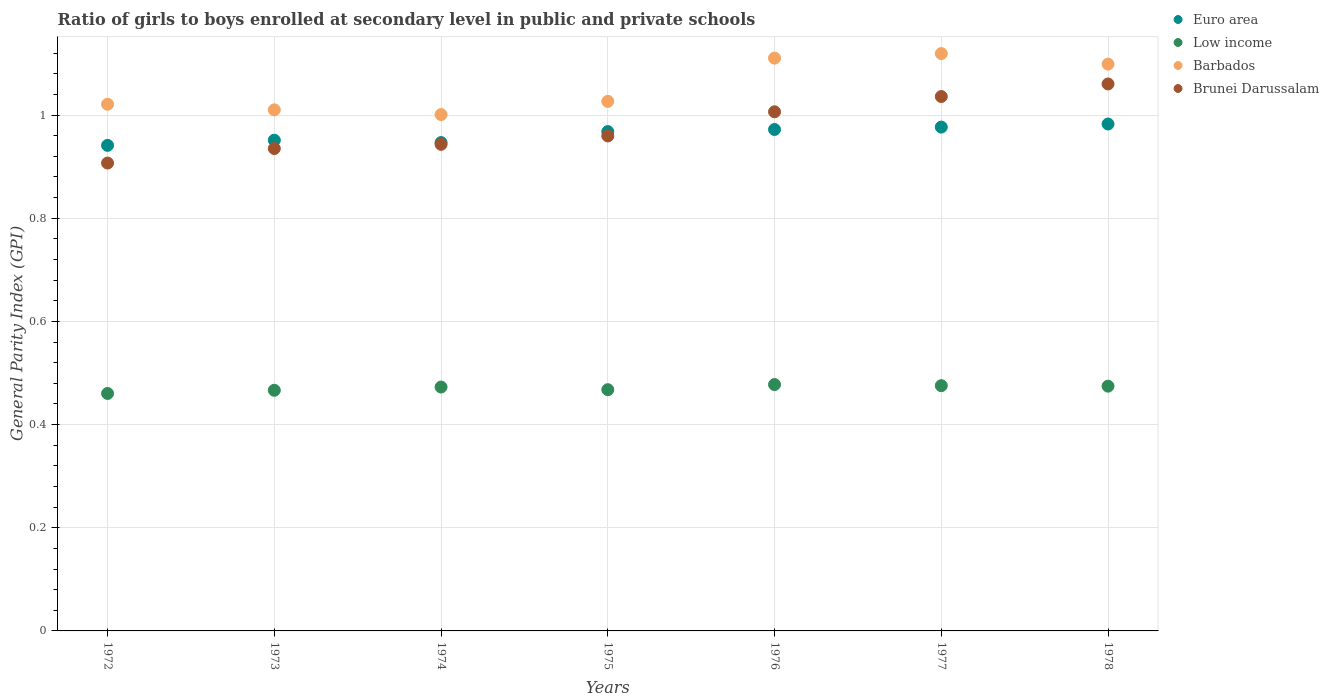How many different coloured dotlines are there?
Ensure brevity in your answer.  4. What is the general parity index in Low income in 1972?
Ensure brevity in your answer.  0.46. Across all years, what is the maximum general parity index in Brunei Darussalam?
Give a very brief answer. 1.06. Across all years, what is the minimum general parity index in Brunei Darussalam?
Offer a terse response. 0.91. In which year was the general parity index in Brunei Darussalam maximum?
Give a very brief answer. 1978. What is the total general parity index in Brunei Darussalam in the graph?
Provide a succinct answer. 6.85. What is the difference between the general parity index in Brunei Darussalam in 1973 and that in 1974?
Provide a short and direct response. -0.01. What is the difference between the general parity index in Low income in 1973 and the general parity index in Brunei Darussalam in 1977?
Provide a short and direct response. -0.57. What is the average general parity index in Brunei Darussalam per year?
Offer a terse response. 0.98. In the year 1974, what is the difference between the general parity index in Euro area and general parity index in Barbados?
Give a very brief answer. -0.05. In how many years, is the general parity index in Low income greater than 0.12?
Offer a terse response. 7. What is the ratio of the general parity index in Brunei Darussalam in 1977 to that in 1978?
Your response must be concise. 0.98. What is the difference between the highest and the second highest general parity index in Low income?
Your answer should be very brief. 0. What is the difference between the highest and the lowest general parity index in Barbados?
Provide a short and direct response. 0.12. Is it the case that in every year, the sum of the general parity index in Barbados and general parity index in Euro area  is greater than the sum of general parity index in Brunei Darussalam and general parity index in Low income?
Offer a terse response. No. Is it the case that in every year, the sum of the general parity index in Euro area and general parity index in Barbados  is greater than the general parity index in Brunei Darussalam?
Ensure brevity in your answer.  Yes. Is the general parity index in Barbados strictly greater than the general parity index in Euro area over the years?
Your answer should be very brief. Yes. Is the general parity index in Euro area strictly less than the general parity index in Barbados over the years?
Your answer should be very brief. Yes. How many dotlines are there?
Give a very brief answer. 4. How many years are there in the graph?
Offer a terse response. 7. What is the difference between two consecutive major ticks on the Y-axis?
Your answer should be very brief. 0.2. Does the graph contain grids?
Give a very brief answer. Yes. Where does the legend appear in the graph?
Provide a short and direct response. Top right. What is the title of the graph?
Your answer should be very brief. Ratio of girls to boys enrolled at secondary level in public and private schools. What is the label or title of the Y-axis?
Offer a terse response. General Parity Index (GPI). What is the General Parity Index (GPI) in Euro area in 1972?
Give a very brief answer. 0.94. What is the General Parity Index (GPI) in Low income in 1972?
Offer a very short reply. 0.46. What is the General Parity Index (GPI) of Barbados in 1972?
Offer a very short reply. 1.02. What is the General Parity Index (GPI) in Brunei Darussalam in 1972?
Your response must be concise. 0.91. What is the General Parity Index (GPI) in Euro area in 1973?
Provide a succinct answer. 0.95. What is the General Parity Index (GPI) of Low income in 1973?
Make the answer very short. 0.47. What is the General Parity Index (GPI) in Barbados in 1973?
Ensure brevity in your answer.  1.01. What is the General Parity Index (GPI) of Brunei Darussalam in 1973?
Ensure brevity in your answer.  0.94. What is the General Parity Index (GPI) of Euro area in 1974?
Ensure brevity in your answer.  0.95. What is the General Parity Index (GPI) of Low income in 1974?
Your answer should be compact. 0.47. What is the General Parity Index (GPI) in Barbados in 1974?
Your answer should be compact. 1. What is the General Parity Index (GPI) of Brunei Darussalam in 1974?
Provide a short and direct response. 0.94. What is the General Parity Index (GPI) in Euro area in 1975?
Provide a succinct answer. 0.97. What is the General Parity Index (GPI) of Low income in 1975?
Your answer should be very brief. 0.47. What is the General Parity Index (GPI) in Barbados in 1975?
Ensure brevity in your answer.  1.03. What is the General Parity Index (GPI) in Brunei Darussalam in 1975?
Provide a succinct answer. 0.96. What is the General Parity Index (GPI) of Euro area in 1976?
Your answer should be very brief. 0.97. What is the General Parity Index (GPI) in Low income in 1976?
Provide a short and direct response. 0.48. What is the General Parity Index (GPI) of Barbados in 1976?
Your response must be concise. 1.11. What is the General Parity Index (GPI) of Brunei Darussalam in 1976?
Provide a short and direct response. 1.01. What is the General Parity Index (GPI) of Euro area in 1977?
Your answer should be compact. 0.98. What is the General Parity Index (GPI) in Low income in 1977?
Provide a short and direct response. 0.48. What is the General Parity Index (GPI) of Barbados in 1977?
Give a very brief answer. 1.12. What is the General Parity Index (GPI) in Brunei Darussalam in 1977?
Give a very brief answer. 1.04. What is the General Parity Index (GPI) in Euro area in 1978?
Provide a succinct answer. 0.98. What is the General Parity Index (GPI) of Low income in 1978?
Make the answer very short. 0.47. What is the General Parity Index (GPI) in Barbados in 1978?
Offer a very short reply. 1.1. What is the General Parity Index (GPI) of Brunei Darussalam in 1978?
Your response must be concise. 1.06. Across all years, what is the maximum General Parity Index (GPI) in Euro area?
Offer a terse response. 0.98. Across all years, what is the maximum General Parity Index (GPI) of Low income?
Give a very brief answer. 0.48. Across all years, what is the maximum General Parity Index (GPI) of Barbados?
Your answer should be very brief. 1.12. Across all years, what is the maximum General Parity Index (GPI) of Brunei Darussalam?
Make the answer very short. 1.06. Across all years, what is the minimum General Parity Index (GPI) in Euro area?
Provide a short and direct response. 0.94. Across all years, what is the minimum General Parity Index (GPI) in Low income?
Your answer should be very brief. 0.46. Across all years, what is the minimum General Parity Index (GPI) in Barbados?
Your answer should be compact. 1. Across all years, what is the minimum General Parity Index (GPI) in Brunei Darussalam?
Make the answer very short. 0.91. What is the total General Parity Index (GPI) of Euro area in the graph?
Your answer should be compact. 6.74. What is the total General Parity Index (GPI) of Low income in the graph?
Provide a succinct answer. 3.29. What is the total General Parity Index (GPI) of Barbados in the graph?
Ensure brevity in your answer.  7.39. What is the total General Parity Index (GPI) of Brunei Darussalam in the graph?
Make the answer very short. 6.85. What is the difference between the General Parity Index (GPI) of Euro area in 1972 and that in 1973?
Provide a short and direct response. -0.01. What is the difference between the General Parity Index (GPI) of Low income in 1972 and that in 1973?
Provide a short and direct response. -0.01. What is the difference between the General Parity Index (GPI) in Barbados in 1972 and that in 1973?
Offer a terse response. 0.01. What is the difference between the General Parity Index (GPI) of Brunei Darussalam in 1972 and that in 1973?
Provide a short and direct response. -0.03. What is the difference between the General Parity Index (GPI) in Euro area in 1972 and that in 1974?
Your answer should be very brief. -0.01. What is the difference between the General Parity Index (GPI) in Low income in 1972 and that in 1974?
Provide a succinct answer. -0.01. What is the difference between the General Parity Index (GPI) of Brunei Darussalam in 1972 and that in 1974?
Give a very brief answer. -0.04. What is the difference between the General Parity Index (GPI) of Euro area in 1972 and that in 1975?
Your response must be concise. -0.03. What is the difference between the General Parity Index (GPI) of Low income in 1972 and that in 1975?
Your answer should be compact. -0.01. What is the difference between the General Parity Index (GPI) in Barbados in 1972 and that in 1975?
Your answer should be very brief. -0.01. What is the difference between the General Parity Index (GPI) in Brunei Darussalam in 1972 and that in 1975?
Your response must be concise. -0.05. What is the difference between the General Parity Index (GPI) of Euro area in 1972 and that in 1976?
Provide a short and direct response. -0.03. What is the difference between the General Parity Index (GPI) of Low income in 1972 and that in 1976?
Provide a succinct answer. -0.02. What is the difference between the General Parity Index (GPI) of Barbados in 1972 and that in 1976?
Offer a terse response. -0.09. What is the difference between the General Parity Index (GPI) in Brunei Darussalam in 1972 and that in 1976?
Offer a terse response. -0.1. What is the difference between the General Parity Index (GPI) in Euro area in 1972 and that in 1977?
Ensure brevity in your answer.  -0.04. What is the difference between the General Parity Index (GPI) of Low income in 1972 and that in 1977?
Make the answer very short. -0.02. What is the difference between the General Parity Index (GPI) of Barbados in 1972 and that in 1977?
Your response must be concise. -0.1. What is the difference between the General Parity Index (GPI) of Brunei Darussalam in 1972 and that in 1977?
Provide a short and direct response. -0.13. What is the difference between the General Parity Index (GPI) of Euro area in 1972 and that in 1978?
Give a very brief answer. -0.04. What is the difference between the General Parity Index (GPI) of Low income in 1972 and that in 1978?
Offer a very short reply. -0.01. What is the difference between the General Parity Index (GPI) of Barbados in 1972 and that in 1978?
Offer a very short reply. -0.08. What is the difference between the General Parity Index (GPI) in Brunei Darussalam in 1972 and that in 1978?
Your answer should be compact. -0.15. What is the difference between the General Parity Index (GPI) of Euro area in 1973 and that in 1974?
Ensure brevity in your answer.  0. What is the difference between the General Parity Index (GPI) in Low income in 1973 and that in 1974?
Your response must be concise. -0.01. What is the difference between the General Parity Index (GPI) in Barbados in 1973 and that in 1974?
Ensure brevity in your answer.  0.01. What is the difference between the General Parity Index (GPI) in Brunei Darussalam in 1973 and that in 1974?
Your answer should be very brief. -0.01. What is the difference between the General Parity Index (GPI) of Euro area in 1973 and that in 1975?
Provide a short and direct response. -0.02. What is the difference between the General Parity Index (GPI) in Low income in 1973 and that in 1975?
Keep it short and to the point. -0. What is the difference between the General Parity Index (GPI) of Barbados in 1973 and that in 1975?
Offer a terse response. -0.02. What is the difference between the General Parity Index (GPI) of Brunei Darussalam in 1973 and that in 1975?
Give a very brief answer. -0.02. What is the difference between the General Parity Index (GPI) of Euro area in 1973 and that in 1976?
Provide a short and direct response. -0.02. What is the difference between the General Parity Index (GPI) in Low income in 1973 and that in 1976?
Your answer should be very brief. -0.01. What is the difference between the General Parity Index (GPI) of Barbados in 1973 and that in 1976?
Your answer should be very brief. -0.1. What is the difference between the General Parity Index (GPI) in Brunei Darussalam in 1973 and that in 1976?
Provide a succinct answer. -0.07. What is the difference between the General Parity Index (GPI) of Euro area in 1973 and that in 1977?
Your response must be concise. -0.03. What is the difference between the General Parity Index (GPI) in Low income in 1973 and that in 1977?
Make the answer very short. -0.01. What is the difference between the General Parity Index (GPI) in Barbados in 1973 and that in 1977?
Keep it short and to the point. -0.11. What is the difference between the General Parity Index (GPI) in Brunei Darussalam in 1973 and that in 1977?
Offer a terse response. -0.1. What is the difference between the General Parity Index (GPI) of Euro area in 1973 and that in 1978?
Keep it short and to the point. -0.03. What is the difference between the General Parity Index (GPI) in Low income in 1973 and that in 1978?
Ensure brevity in your answer.  -0.01. What is the difference between the General Parity Index (GPI) in Barbados in 1973 and that in 1978?
Provide a succinct answer. -0.09. What is the difference between the General Parity Index (GPI) in Brunei Darussalam in 1973 and that in 1978?
Keep it short and to the point. -0.13. What is the difference between the General Parity Index (GPI) in Euro area in 1974 and that in 1975?
Give a very brief answer. -0.02. What is the difference between the General Parity Index (GPI) of Low income in 1974 and that in 1975?
Provide a short and direct response. 0.01. What is the difference between the General Parity Index (GPI) of Barbados in 1974 and that in 1975?
Ensure brevity in your answer.  -0.03. What is the difference between the General Parity Index (GPI) in Brunei Darussalam in 1974 and that in 1975?
Give a very brief answer. -0.02. What is the difference between the General Parity Index (GPI) of Euro area in 1974 and that in 1976?
Offer a terse response. -0.03. What is the difference between the General Parity Index (GPI) in Low income in 1974 and that in 1976?
Your answer should be very brief. -0. What is the difference between the General Parity Index (GPI) in Barbados in 1974 and that in 1976?
Provide a succinct answer. -0.11. What is the difference between the General Parity Index (GPI) in Brunei Darussalam in 1974 and that in 1976?
Provide a succinct answer. -0.06. What is the difference between the General Parity Index (GPI) of Euro area in 1974 and that in 1977?
Keep it short and to the point. -0.03. What is the difference between the General Parity Index (GPI) in Low income in 1974 and that in 1977?
Your answer should be compact. -0. What is the difference between the General Parity Index (GPI) in Barbados in 1974 and that in 1977?
Your response must be concise. -0.12. What is the difference between the General Parity Index (GPI) in Brunei Darussalam in 1974 and that in 1977?
Ensure brevity in your answer.  -0.09. What is the difference between the General Parity Index (GPI) of Euro area in 1974 and that in 1978?
Keep it short and to the point. -0.04. What is the difference between the General Parity Index (GPI) of Low income in 1974 and that in 1978?
Provide a short and direct response. -0. What is the difference between the General Parity Index (GPI) in Barbados in 1974 and that in 1978?
Your answer should be very brief. -0.1. What is the difference between the General Parity Index (GPI) in Brunei Darussalam in 1974 and that in 1978?
Provide a succinct answer. -0.12. What is the difference between the General Parity Index (GPI) in Euro area in 1975 and that in 1976?
Your response must be concise. -0. What is the difference between the General Parity Index (GPI) in Low income in 1975 and that in 1976?
Keep it short and to the point. -0.01. What is the difference between the General Parity Index (GPI) of Barbados in 1975 and that in 1976?
Ensure brevity in your answer.  -0.08. What is the difference between the General Parity Index (GPI) in Brunei Darussalam in 1975 and that in 1976?
Ensure brevity in your answer.  -0.05. What is the difference between the General Parity Index (GPI) in Euro area in 1975 and that in 1977?
Keep it short and to the point. -0.01. What is the difference between the General Parity Index (GPI) of Low income in 1975 and that in 1977?
Offer a very short reply. -0.01. What is the difference between the General Parity Index (GPI) in Barbados in 1975 and that in 1977?
Give a very brief answer. -0.09. What is the difference between the General Parity Index (GPI) of Brunei Darussalam in 1975 and that in 1977?
Make the answer very short. -0.08. What is the difference between the General Parity Index (GPI) in Euro area in 1975 and that in 1978?
Ensure brevity in your answer.  -0.01. What is the difference between the General Parity Index (GPI) of Low income in 1975 and that in 1978?
Offer a very short reply. -0.01. What is the difference between the General Parity Index (GPI) of Barbados in 1975 and that in 1978?
Provide a short and direct response. -0.07. What is the difference between the General Parity Index (GPI) of Brunei Darussalam in 1975 and that in 1978?
Offer a terse response. -0.1. What is the difference between the General Parity Index (GPI) in Euro area in 1976 and that in 1977?
Keep it short and to the point. -0. What is the difference between the General Parity Index (GPI) of Low income in 1976 and that in 1977?
Ensure brevity in your answer.  0. What is the difference between the General Parity Index (GPI) of Barbados in 1976 and that in 1977?
Offer a terse response. -0.01. What is the difference between the General Parity Index (GPI) of Brunei Darussalam in 1976 and that in 1977?
Offer a terse response. -0.03. What is the difference between the General Parity Index (GPI) in Euro area in 1976 and that in 1978?
Ensure brevity in your answer.  -0.01. What is the difference between the General Parity Index (GPI) in Low income in 1976 and that in 1978?
Give a very brief answer. 0. What is the difference between the General Parity Index (GPI) in Barbados in 1976 and that in 1978?
Your answer should be very brief. 0.01. What is the difference between the General Parity Index (GPI) of Brunei Darussalam in 1976 and that in 1978?
Keep it short and to the point. -0.05. What is the difference between the General Parity Index (GPI) in Euro area in 1977 and that in 1978?
Give a very brief answer. -0.01. What is the difference between the General Parity Index (GPI) in Barbados in 1977 and that in 1978?
Your response must be concise. 0.02. What is the difference between the General Parity Index (GPI) of Brunei Darussalam in 1977 and that in 1978?
Your answer should be very brief. -0.02. What is the difference between the General Parity Index (GPI) of Euro area in 1972 and the General Parity Index (GPI) of Low income in 1973?
Provide a succinct answer. 0.47. What is the difference between the General Parity Index (GPI) in Euro area in 1972 and the General Parity Index (GPI) in Barbados in 1973?
Offer a terse response. -0.07. What is the difference between the General Parity Index (GPI) of Euro area in 1972 and the General Parity Index (GPI) of Brunei Darussalam in 1973?
Provide a succinct answer. 0.01. What is the difference between the General Parity Index (GPI) in Low income in 1972 and the General Parity Index (GPI) in Barbados in 1973?
Offer a very short reply. -0.55. What is the difference between the General Parity Index (GPI) of Low income in 1972 and the General Parity Index (GPI) of Brunei Darussalam in 1973?
Ensure brevity in your answer.  -0.47. What is the difference between the General Parity Index (GPI) of Barbados in 1972 and the General Parity Index (GPI) of Brunei Darussalam in 1973?
Your answer should be compact. 0.09. What is the difference between the General Parity Index (GPI) in Euro area in 1972 and the General Parity Index (GPI) in Low income in 1974?
Give a very brief answer. 0.47. What is the difference between the General Parity Index (GPI) of Euro area in 1972 and the General Parity Index (GPI) of Barbados in 1974?
Keep it short and to the point. -0.06. What is the difference between the General Parity Index (GPI) of Euro area in 1972 and the General Parity Index (GPI) of Brunei Darussalam in 1974?
Make the answer very short. -0. What is the difference between the General Parity Index (GPI) of Low income in 1972 and the General Parity Index (GPI) of Barbados in 1974?
Provide a short and direct response. -0.54. What is the difference between the General Parity Index (GPI) in Low income in 1972 and the General Parity Index (GPI) in Brunei Darussalam in 1974?
Provide a short and direct response. -0.48. What is the difference between the General Parity Index (GPI) in Barbados in 1972 and the General Parity Index (GPI) in Brunei Darussalam in 1974?
Ensure brevity in your answer.  0.08. What is the difference between the General Parity Index (GPI) of Euro area in 1972 and the General Parity Index (GPI) of Low income in 1975?
Give a very brief answer. 0.47. What is the difference between the General Parity Index (GPI) in Euro area in 1972 and the General Parity Index (GPI) in Barbados in 1975?
Keep it short and to the point. -0.09. What is the difference between the General Parity Index (GPI) in Euro area in 1972 and the General Parity Index (GPI) in Brunei Darussalam in 1975?
Provide a succinct answer. -0.02. What is the difference between the General Parity Index (GPI) in Low income in 1972 and the General Parity Index (GPI) in Barbados in 1975?
Provide a succinct answer. -0.57. What is the difference between the General Parity Index (GPI) of Low income in 1972 and the General Parity Index (GPI) of Brunei Darussalam in 1975?
Offer a very short reply. -0.5. What is the difference between the General Parity Index (GPI) of Barbados in 1972 and the General Parity Index (GPI) of Brunei Darussalam in 1975?
Offer a very short reply. 0.06. What is the difference between the General Parity Index (GPI) of Euro area in 1972 and the General Parity Index (GPI) of Low income in 1976?
Provide a succinct answer. 0.46. What is the difference between the General Parity Index (GPI) in Euro area in 1972 and the General Parity Index (GPI) in Barbados in 1976?
Provide a succinct answer. -0.17. What is the difference between the General Parity Index (GPI) of Euro area in 1972 and the General Parity Index (GPI) of Brunei Darussalam in 1976?
Provide a succinct answer. -0.07. What is the difference between the General Parity Index (GPI) in Low income in 1972 and the General Parity Index (GPI) in Barbados in 1976?
Your answer should be compact. -0.65. What is the difference between the General Parity Index (GPI) of Low income in 1972 and the General Parity Index (GPI) of Brunei Darussalam in 1976?
Offer a very short reply. -0.55. What is the difference between the General Parity Index (GPI) of Barbados in 1972 and the General Parity Index (GPI) of Brunei Darussalam in 1976?
Keep it short and to the point. 0.01. What is the difference between the General Parity Index (GPI) in Euro area in 1972 and the General Parity Index (GPI) in Low income in 1977?
Your answer should be compact. 0.47. What is the difference between the General Parity Index (GPI) of Euro area in 1972 and the General Parity Index (GPI) of Barbados in 1977?
Your response must be concise. -0.18. What is the difference between the General Parity Index (GPI) in Euro area in 1972 and the General Parity Index (GPI) in Brunei Darussalam in 1977?
Your answer should be very brief. -0.09. What is the difference between the General Parity Index (GPI) in Low income in 1972 and the General Parity Index (GPI) in Barbados in 1977?
Ensure brevity in your answer.  -0.66. What is the difference between the General Parity Index (GPI) of Low income in 1972 and the General Parity Index (GPI) of Brunei Darussalam in 1977?
Offer a terse response. -0.58. What is the difference between the General Parity Index (GPI) in Barbados in 1972 and the General Parity Index (GPI) in Brunei Darussalam in 1977?
Your answer should be compact. -0.01. What is the difference between the General Parity Index (GPI) of Euro area in 1972 and the General Parity Index (GPI) of Low income in 1978?
Your response must be concise. 0.47. What is the difference between the General Parity Index (GPI) in Euro area in 1972 and the General Parity Index (GPI) in Barbados in 1978?
Provide a succinct answer. -0.16. What is the difference between the General Parity Index (GPI) of Euro area in 1972 and the General Parity Index (GPI) of Brunei Darussalam in 1978?
Your response must be concise. -0.12. What is the difference between the General Parity Index (GPI) of Low income in 1972 and the General Parity Index (GPI) of Barbados in 1978?
Make the answer very short. -0.64. What is the difference between the General Parity Index (GPI) of Low income in 1972 and the General Parity Index (GPI) of Brunei Darussalam in 1978?
Ensure brevity in your answer.  -0.6. What is the difference between the General Parity Index (GPI) of Barbados in 1972 and the General Parity Index (GPI) of Brunei Darussalam in 1978?
Your answer should be very brief. -0.04. What is the difference between the General Parity Index (GPI) in Euro area in 1973 and the General Parity Index (GPI) in Low income in 1974?
Offer a terse response. 0.48. What is the difference between the General Parity Index (GPI) in Euro area in 1973 and the General Parity Index (GPI) in Barbados in 1974?
Make the answer very short. -0.05. What is the difference between the General Parity Index (GPI) of Euro area in 1973 and the General Parity Index (GPI) of Brunei Darussalam in 1974?
Offer a very short reply. 0.01. What is the difference between the General Parity Index (GPI) in Low income in 1973 and the General Parity Index (GPI) in Barbados in 1974?
Make the answer very short. -0.53. What is the difference between the General Parity Index (GPI) in Low income in 1973 and the General Parity Index (GPI) in Brunei Darussalam in 1974?
Your answer should be very brief. -0.48. What is the difference between the General Parity Index (GPI) in Barbados in 1973 and the General Parity Index (GPI) in Brunei Darussalam in 1974?
Keep it short and to the point. 0.07. What is the difference between the General Parity Index (GPI) of Euro area in 1973 and the General Parity Index (GPI) of Low income in 1975?
Make the answer very short. 0.48. What is the difference between the General Parity Index (GPI) of Euro area in 1973 and the General Parity Index (GPI) of Barbados in 1975?
Offer a terse response. -0.08. What is the difference between the General Parity Index (GPI) in Euro area in 1973 and the General Parity Index (GPI) in Brunei Darussalam in 1975?
Your response must be concise. -0.01. What is the difference between the General Parity Index (GPI) in Low income in 1973 and the General Parity Index (GPI) in Barbados in 1975?
Provide a succinct answer. -0.56. What is the difference between the General Parity Index (GPI) of Low income in 1973 and the General Parity Index (GPI) of Brunei Darussalam in 1975?
Keep it short and to the point. -0.49. What is the difference between the General Parity Index (GPI) of Barbados in 1973 and the General Parity Index (GPI) of Brunei Darussalam in 1975?
Ensure brevity in your answer.  0.05. What is the difference between the General Parity Index (GPI) of Euro area in 1973 and the General Parity Index (GPI) of Low income in 1976?
Offer a terse response. 0.47. What is the difference between the General Parity Index (GPI) in Euro area in 1973 and the General Parity Index (GPI) in Barbados in 1976?
Offer a terse response. -0.16. What is the difference between the General Parity Index (GPI) in Euro area in 1973 and the General Parity Index (GPI) in Brunei Darussalam in 1976?
Your answer should be very brief. -0.06. What is the difference between the General Parity Index (GPI) of Low income in 1973 and the General Parity Index (GPI) of Barbados in 1976?
Ensure brevity in your answer.  -0.64. What is the difference between the General Parity Index (GPI) of Low income in 1973 and the General Parity Index (GPI) of Brunei Darussalam in 1976?
Provide a succinct answer. -0.54. What is the difference between the General Parity Index (GPI) of Barbados in 1973 and the General Parity Index (GPI) of Brunei Darussalam in 1976?
Offer a terse response. 0. What is the difference between the General Parity Index (GPI) of Euro area in 1973 and the General Parity Index (GPI) of Low income in 1977?
Provide a succinct answer. 0.48. What is the difference between the General Parity Index (GPI) of Euro area in 1973 and the General Parity Index (GPI) of Barbados in 1977?
Your answer should be compact. -0.17. What is the difference between the General Parity Index (GPI) in Euro area in 1973 and the General Parity Index (GPI) in Brunei Darussalam in 1977?
Your response must be concise. -0.08. What is the difference between the General Parity Index (GPI) of Low income in 1973 and the General Parity Index (GPI) of Barbados in 1977?
Your response must be concise. -0.65. What is the difference between the General Parity Index (GPI) in Low income in 1973 and the General Parity Index (GPI) in Brunei Darussalam in 1977?
Provide a short and direct response. -0.57. What is the difference between the General Parity Index (GPI) of Barbados in 1973 and the General Parity Index (GPI) of Brunei Darussalam in 1977?
Provide a succinct answer. -0.03. What is the difference between the General Parity Index (GPI) in Euro area in 1973 and the General Parity Index (GPI) in Low income in 1978?
Ensure brevity in your answer.  0.48. What is the difference between the General Parity Index (GPI) in Euro area in 1973 and the General Parity Index (GPI) in Barbados in 1978?
Offer a very short reply. -0.15. What is the difference between the General Parity Index (GPI) of Euro area in 1973 and the General Parity Index (GPI) of Brunei Darussalam in 1978?
Give a very brief answer. -0.11. What is the difference between the General Parity Index (GPI) in Low income in 1973 and the General Parity Index (GPI) in Barbados in 1978?
Provide a short and direct response. -0.63. What is the difference between the General Parity Index (GPI) in Low income in 1973 and the General Parity Index (GPI) in Brunei Darussalam in 1978?
Keep it short and to the point. -0.59. What is the difference between the General Parity Index (GPI) in Barbados in 1973 and the General Parity Index (GPI) in Brunei Darussalam in 1978?
Ensure brevity in your answer.  -0.05. What is the difference between the General Parity Index (GPI) of Euro area in 1974 and the General Parity Index (GPI) of Low income in 1975?
Offer a terse response. 0.48. What is the difference between the General Parity Index (GPI) of Euro area in 1974 and the General Parity Index (GPI) of Barbados in 1975?
Offer a terse response. -0.08. What is the difference between the General Parity Index (GPI) in Euro area in 1974 and the General Parity Index (GPI) in Brunei Darussalam in 1975?
Give a very brief answer. -0.01. What is the difference between the General Parity Index (GPI) in Low income in 1974 and the General Parity Index (GPI) in Barbados in 1975?
Offer a very short reply. -0.55. What is the difference between the General Parity Index (GPI) in Low income in 1974 and the General Parity Index (GPI) in Brunei Darussalam in 1975?
Give a very brief answer. -0.49. What is the difference between the General Parity Index (GPI) of Barbados in 1974 and the General Parity Index (GPI) of Brunei Darussalam in 1975?
Provide a short and direct response. 0.04. What is the difference between the General Parity Index (GPI) in Euro area in 1974 and the General Parity Index (GPI) in Low income in 1976?
Your answer should be very brief. 0.47. What is the difference between the General Parity Index (GPI) of Euro area in 1974 and the General Parity Index (GPI) of Barbados in 1976?
Your answer should be compact. -0.16. What is the difference between the General Parity Index (GPI) of Euro area in 1974 and the General Parity Index (GPI) of Brunei Darussalam in 1976?
Keep it short and to the point. -0.06. What is the difference between the General Parity Index (GPI) in Low income in 1974 and the General Parity Index (GPI) in Barbados in 1976?
Make the answer very short. -0.64. What is the difference between the General Parity Index (GPI) of Low income in 1974 and the General Parity Index (GPI) of Brunei Darussalam in 1976?
Offer a terse response. -0.53. What is the difference between the General Parity Index (GPI) of Barbados in 1974 and the General Parity Index (GPI) of Brunei Darussalam in 1976?
Your response must be concise. -0.01. What is the difference between the General Parity Index (GPI) in Euro area in 1974 and the General Parity Index (GPI) in Low income in 1977?
Your answer should be compact. 0.47. What is the difference between the General Parity Index (GPI) of Euro area in 1974 and the General Parity Index (GPI) of Barbados in 1977?
Offer a very short reply. -0.17. What is the difference between the General Parity Index (GPI) of Euro area in 1974 and the General Parity Index (GPI) of Brunei Darussalam in 1977?
Ensure brevity in your answer.  -0.09. What is the difference between the General Parity Index (GPI) of Low income in 1974 and the General Parity Index (GPI) of Barbados in 1977?
Offer a terse response. -0.65. What is the difference between the General Parity Index (GPI) of Low income in 1974 and the General Parity Index (GPI) of Brunei Darussalam in 1977?
Keep it short and to the point. -0.56. What is the difference between the General Parity Index (GPI) in Barbados in 1974 and the General Parity Index (GPI) in Brunei Darussalam in 1977?
Your response must be concise. -0.04. What is the difference between the General Parity Index (GPI) of Euro area in 1974 and the General Parity Index (GPI) of Low income in 1978?
Your answer should be very brief. 0.47. What is the difference between the General Parity Index (GPI) of Euro area in 1974 and the General Parity Index (GPI) of Barbados in 1978?
Your answer should be very brief. -0.15. What is the difference between the General Parity Index (GPI) of Euro area in 1974 and the General Parity Index (GPI) of Brunei Darussalam in 1978?
Your answer should be very brief. -0.11. What is the difference between the General Parity Index (GPI) of Low income in 1974 and the General Parity Index (GPI) of Barbados in 1978?
Offer a terse response. -0.63. What is the difference between the General Parity Index (GPI) of Low income in 1974 and the General Parity Index (GPI) of Brunei Darussalam in 1978?
Offer a terse response. -0.59. What is the difference between the General Parity Index (GPI) of Barbados in 1974 and the General Parity Index (GPI) of Brunei Darussalam in 1978?
Keep it short and to the point. -0.06. What is the difference between the General Parity Index (GPI) of Euro area in 1975 and the General Parity Index (GPI) of Low income in 1976?
Provide a succinct answer. 0.49. What is the difference between the General Parity Index (GPI) in Euro area in 1975 and the General Parity Index (GPI) in Barbados in 1976?
Give a very brief answer. -0.14. What is the difference between the General Parity Index (GPI) in Euro area in 1975 and the General Parity Index (GPI) in Brunei Darussalam in 1976?
Ensure brevity in your answer.  -0.04. What is the difference between the General Parity Index (GPI) in Low income in 1975 and the General Parity Index (GPI) in Barbados in 1976?
Ensure brevity in your answer.  -0.64. What is the difference between the General Parity Index (GPI) in Low income in 1975 and the General Parity Index (GPI) in Brunei Darussalam in 1976?
Keep it short and to the point. -0.54. What is the difference between the General Parity Index (GPI) of Barbados in 1975 and the General Parity Index (GPI) of Brunei Darussalam in 1976?
Your response must be concise. 0.02. What is the difference between the General Parity Index (GPI) of Euro area in 1975 and the General Parity Index (GPI) of Low income in 1977?
Offer a very short reply. 0.49. What is the difference between the General Parity Index (GPI) in Euro area in 1975 and the General Parity Index (GPI) in Barbados in 1977?
Provide a short and direct response. -0.15. What is the difference between the General Parity Index (GPI) in Euro area in 1975 and the General Parity Index (GPI) in Brunei Darussalam in 1977?
Your answer should be compact. -0.07. What is the difference between the General Parity Index (GPI) of Low income in 1975 and the General Parity Index (GPI) of Barbados in 1977?
Ensure brevity in your answer.  -0.65. What is the difference between the General Parity Index (GPI) in Low income in 1975 and the General Parity Index (GPI) in Brunei Darussalam in 1977?
Make the answer very short. -0.57. What is the difference between the General Parity Index (GPI) in Barbados in 1975 and the General Parity Index (GPI) in Brunei Darussalam in 1977?
Give a very brief answer. -0.01. What is the difference between the General Parity Index (GPI) in Euro area in 1975 and the General Parity Index (GPI) in Low income in 1978?
Ensure brevity in your answer.  0.49. What is the difference between the General Parity Index (GPI) of Euro area in 1975 and the General Parity Index (GPI) of Barbados in 1978?
Offer a terse response. -0.13. What is the difference between the General Parity Index (GPI) in Euro area in 1975 and the General Parity Index (GPI) in Brunei Darussalam in 1978?
Your response must be concise. -0.09. What is the difference between the General Parity Index (GPI) of Low income in 1975 and the General Parity Index (GPI) of Barbados in 1978?
Your response must be concise. -0.63. What is the difference between the General Parity Index (GPI) in Low income in 1975 and the General Parity Index (GPI) in Brunei Darussalam in 1978?
Your answer should be compact. -0.59. What is the difference between the General Parity Index (GPI) in Barbados in 1975 and the General Parity Index (GPI) in Brunei Darussalam in 1978?
Provide a succinct answer. -0.03. What is the difference between the General Parity Index (GPI) in Euro area in 1976 and the General Parity Index (GPI) in Low income in 1977?
Offer a very short reply. 0.5. What is the difference between the General Parity Index (GPI) of Euro area in 1976 and the General Parity Index (GPI) of Barbados in 1977?
Give a very brief answer. -0.15. What is the difference between the General Parity Index (GPI) in Euro area in 1976 and the General Parity Index (GPI) in Brunei Darussalam in 1977?
Give a very brief answer. -0.06. What is the difference between the General Parity Index (GPI) in Low income in 1976 and the General Parity Index (GPI) in Barbados in 1977?
Give a very brief answer. -0.64. What is the difference between the General Parity Index (GPI) of Low income in 1976 and the General Parity Index (GPI) of Brunei Darussalam in 1977?
Provide a short and direct response. -0.56. What is the difference between the General Parity Index (GPI) in Barbados in 1976 and the General Parity Index (GPI) in Brunei Darussalam in 1977?
Offer a terse response. 0.07. What is the difference between the General Parity Index (GPI) in Euro area in 1976 and the General Parity Index (GPI) in Low income in 1978?
Provide a succinct answer. 0.5. What is the difference between the General Parity Index (GPI) in Euro area in 1976 and the General Parity Index (GPI) in Barbados in 1978?
Offer a terse response. -0.13. What is the difference between the General Parity Index (GPI) of Euro area in 1976 and the General Parity Index (GPI) of Brunei Darussalam in 1978?
Your answer should be compact. -0.09. What is the difference between the General Parity Index (GPI) of Low income in 1976 and the General Parity Index (GPI) of Barbados in 1978?
Provide a short and direct response. -0.62. What is the difference between the General Parity Index (GPI) of Low income in 1976 and the General Parity Index (GPI) of Brunei Darussalam in 1978?
Ensure brevity in your answer.  -0.58. What is the difference between the General Parity Index (GPI) in Barbados in 1976 and the General Parity Index (GPI) in Brunei Darussalam in 1978?
Ensure brevity in your answer.  0.05. What is the difference between the General Parity Index (GPI) in Euro area in 1977 and the General Parity Index (GPI) in Low income in 1978?
Offer a very short reply. 0.5. What is the difference between the General Parity Index (GPI) in Euro area in 1977 and the General Parity Index (GPI) in Barbados in 1978?
Offer a terse response. -0.12. What is the difference between the General Parity Index (GPI) in Euro area in 1977 and the General Parity Index (GPI) in Brunei Darussalam in 1978?
Give a very brief answer. -0.08. What is the difference between the General Parity Index (GPI) of Low income in 1977 and the General Parity Index (GPI) of Barbados in 1978?
Your answer should be compact. -0.62. What is the difference between the General Parity Index (GPI) in Low income in 1977 and the General Parity Index (GPI) in Brunei Darussalam in 1978?
Ensure brevity in your answer.  -0.58. What is the difference between the General Parity Index (GPI) in Barbados in 1977 and the General Parity Index (GPI) in Brunei Darussalam in 1978?
Offer a terse response. 0.06. What is the average General Parity Index (GPI) of Euro area per year?
Make the answer very short. 0.96. What is the average General Parity Index (GPI) of Low income per year?
Your answer should be very brief. 0.47. What is the average General Parity Index (GPI) of Barbados per year?
Ensure brevity in your answer.  1.06. What is the average General Parity Index (GPI) of Brunei Darussalam per year?
Provide a succinct answer. 0.98. In the year 1972, what is the difference between the General Parity Index (GPI) in Euro area and General Parity Index (GPI) in Low income?
Give a very brief answer. 0.48. In the year 1972, what is the difference between the General Parity Index (GPI) in Euro area and General Parity Index (GPI) in Barbados?
Give a very brief answer. -0.08. In the year 1972, what is the difference between the General Parity Index (GPI) of Euro area and General Parity Index (GPI) of Brunei Darussalam?
Provide a succinct answer. 0.03. In the year 1972, what is the difference between the General Parity Index (GPI) in Low income and General Parity Index (GPI) in Barbados?
Offer a terse response. -0.56. In the year 1972, what is the difference between the General Parity Index (GPI) in Low income and General Parity Index (GPI) in Brunei Darussalam?
Provide a succinct answer. -0.45. In the year 1972, what is the difference between the General Parity Index (GPI) in Barbados and General Parity Index (GPI) in Brunei Darussalam?
Your response must be concise. 0.11. In the year 1973, what is the difference between the General Parity Index (GPI) in Euro area and General Parity Index (GPI) in Low income?
Your answer should be very brief. 0.48. In the year 1973, what is the difference between the General Parity Index (GPI) of Euro area and General Parity Index (GPI) of Barbados?
Your answer should be very brief. -0.06. In the year 1973, what is the difference between the General Parity Index (GPI) in Euro area and General Parity Index (GPI) in Brunei Darussalam?
Your response must be concise. 0.02. In the year 1973, what is the difference between the General Parity Index (GPI) of Low income and General Parity Index (GPI) of Barbados?
Give a very brief answer. -0.54. In the year 1973, what is the difference between the General Parity Index (GPI) of Low income and General Parity Index (GPI) of Brunei Darussalam?
Provide a short and direct response. -0.47. In the year 1973, what is the difference between the General Parity Index (GPI) in Barbados and General Parity Index (GPI) in Brunei Darussalam?
Your response must be concise. 0.07. In the year 1974, what is the difference between the General Parity Index (GPI) in Euro area and General Parity Index (GPI) in Low income?
Offer a terse response. 0.47. In the year 1974, what is the difference between the General Parity Index (GPI) in Euro area and General Parity Index (GPI) in Barbados?
Ensure brevity in your answer.  -0.05. In the year 1974, what is the difference between the General Parity Index (GPI) of Euro area and General Parity Index (GPI) of Brunei Darussalam?
Your answer should be compact. 0. In the year 1974, what is the difference between the General Parity Index (GPI) in Low income and General Parity Index (GPI) in Barbados?
Offer a terse response. -0.53. In the year 1974, what is the difference between the General Parity Index (GPI) in Low income and General Parity Index (GPI) in Brunei Darussalam?
Give a very brief answer. -0.47. In the year 1974, what is the difference between the General Parity Index (GPI) of Barbados and General Parity Index (GPI) of Brunei Darussalam?
Offer a very short reply. 0.06. In the year 1975, what is the difference between the General Parity Index (GPI) of Euro area and General Parity Index (GPI) of Low income?
Make the answer very short. 0.5. In the year 1975, what is the difference between the General Parity Index (GPI) of Euro area and General Parity Index (GPI) of Barbados?
Offer a very short reply. -0.06. In the year 1975, what is the difference between the General Parity Index (GPI) of Euro area and General Parity Index (GPI) of Brunei Darussalam?
Offer a terse response. 0.01. In the year 1975, what is the difference between the General Parity Index (GPI) in Low income and General Parity Index (GPI) in Barbados?
Give a very brief answer. -0.56. In the year 1975, what is the difference between the General Parity Index (GPI) in Low income and General Parity Index (GPI) in Brunei Darussalam?
Your response must be concise. -0.49. In the year 1975, what is the difference between the General Parity Index (GPI) in Barbados and General Parity Index (GPI) in Brunei Darussalam?
Keep it short and to the point. 0.07. In the year 1976, what is the difference between the General Parity Index (GPI) of Euro area and General Parity Index (GPI) of Low income?
Make the answer very short. 0.49. In the year 1976, what is the difference between the General Parity Index (GPI) in Euro area and General Parity Index (GPI) in Barbados?
Make the answer very short. -0.14. In the year 1976, what is the difference between the General Parity Index (GPI) of Euro area and General Parity Index (GPI) of Brunei Darussalam?
Give a very brief answer. -0.03. In the year 1976, what is the difference between the General Parity Index (GPI) in Low income and General Parity Index (GPI) in Barbados?
Keep it short and to the point. -0.63. In the year 1976, what is the difference between the General Parity Index (GPI) in Low income and General Parity Index (GPI) in Brunei Darussalam?
Your answer should be very brief. -0.53. In the year 1976, what is the difference between the General Parity Index (GPI) of Barbados and General Parity Index (GPI) of Brunei Darussalam?
Provide a short and direct response. 0.1. In the year 1977, what is the difference between the General Parity Index (GPI) of Euro area and General Parity Index (GPI) of Low income?
Keep it short and to the point. 0.5. In the year 1977, what is the difference between the General Parity Index (GPI) of Euro area and General Parity Index (GPI) of Barbados?
Give a very brief answer. -0.14. In the year 1977, what is the difference between the General Parity Index (GPI) in Euro area and General Parity Index (GPI) in Brunei Darussalam?
Your answer should be compact. -0.06. In the year 1977, what is the difference between the General Parity Index (GPI) in Low income and General Parity Index (GPI) in Barbados?
Your response must be concise. -0.64. In the year 1977, what is the difference between the General Parity Index (GPI) in Low income and General Parity Index (GPI) in Brunei Darussalam?
Your answer should be compact. -0.56. In the year 1977, what is the difference between the General Parity Index (GPI) of Barbados and General Parity Index (GPI) of Brunei Darussalam?
Make the answer very short. 0.08. In the year 1978, what is the difference between the General Parity Index (GPI) in Euro area and General Parity Index (GPI) in Low income?
Make the answer very short. 0.51. In the year 1978, what is the difference between the General Parity Index (GPI) in Euro area and General Parity Index (GPI) in Barbados?
Ensure brevity in your answer.  -0.12. In the year 1978, what is the difference between the General Parity Index (GPI) in Euro area and General Parity Index (GPI) in Brunei Darussalam?
Offer a terse response. -0.08. In the year 1978, what is the difference between the General Parity Index (GPI) in Low income and General Parity Index (GPI) in Barbados?
Your response must be concise. -0.62. In the year 1978, what is the difference between the General Parity Index (GPI) of Low income and General Parity Index (GPI) of Brunei Darussalam?
Give a very brief answer. -0.59. In the year 1978, what is the difference between the General Parity Index (GPI) of Barbados and General Parity Index (GPI) of Brunei Darussalam?
Your response must be concise. 0.04. What is the ratio of the General Parity Index (GPI) in Barbados in 1972 to that in 1973?
Your answer should be compact. 1.01. What is the ratio of the General Parity Index (GPI) of Brunei Darussalam in 1972 to that in 1973?
Your response must be concise. 0.97. What is the ratio of the General Parity Index (GPI) in Euro area in 1972 to that in 1974?
Provide a short and direct response. 0.99. What is the ratio of the General Parity Index (GPI) in Low income in 1972 to that in 1974?
Ensure brevity in your answer.  0.97. What is the ratio of the General Parity Index (GPI) of Brunei Darussalam in 1972 to that in 1974?
Keep it short and to the point. 0.96. What is the ratio of the General Parity Index (GPI) in Euro area in 1972 to that in 1975?
Make the answer very short. 0.97. What is the ratio of the General Parity Index (GPI) of Low income in 1972 to that in 1975?
Offer a very short reply. 0.98. What is the ratio of the General Parity Index (GPI) of Brunei Darussalam in 1972 to that in 1975?
Provide a short and direct response. 0.95. What is the ratio of the General Parity Index (GPI) in Euro area in 1972 to that in 1976?
Make the answer very short. 0.97. What is the ratio of the General Parity Index (GPI) in Low income in 1972 to that in 1976?
Offer a terse response. 0.96. What is the ratio of the General Parity Index (GPI) of Barbados in 1972 to that in 1976?
Offer a very short reply. 0.92. What is the ratio of the General Parity Index (GPI) of Brunei Darussalam in 1972 to that in 1976?
Make the answer very short. 0.9. What is the ratio of the General Parity Index (GPI) of Euro area in 1972 to that in 1977?
Keep it short and to the point. 0.96. What is the ratio of the General Parity Index (GPI) of Low income in 1972 to that in 1977?
Keep it short and to the point. 0.97. What is the ratio of the General Parity Index (GPI) in Barbados in 1972 to that in 1977?
Ensure brevity in your answer.  0.91. What is the ratio of the General Parity Index (GPI) in Brunei Darussalam in 1972 to that in 1977?
Ensure brevity in your answer.  0.88. What is the ratio of the General Parity Index (GPI) of Euro area in 1972 to that in 1978?
Your answer should be compact. 0.96. What is the ratio of the General Parity Index (GPI) in Low income in 1972 to that in 1978?
Your response must be concise. 0.97. What is the ratio of the General Parity Index (GPI) in Barbados in 1972 to that in 1978?
Keep it short and to the point. 0.93. What is the ratio of the General Parity Index (GPI) in Brunei Darussalam in 1972 to that in 1978?
Your answer should be compact. 0.86. What is the ratio of the General Parity Index (GPI) of Euro area in 1973 to that in 1974?
Make the answer very short. 1. What is the ratio of the General Parity Index (GPI) in Low income in 1973 to that in 1974?
Your response must be concise. 0.99. What is the ratio of the General Parity Index (GPI) of Barbados in 1973 to that in 1974?
Ensure brevity in your answer.  1.01. What is the ratio of the General Parity Index (GPI) of Brunei Darussalam in 1973 to that in 1974?
Your answer should be compact. 0.99. What is the ratio of the General Parity Index (GPI) of Euro area in 1973 to that in 1975?
Make the answer very short. 0.98. What is the ratio of the General Parity Index (GPI) in Low income in 1973 to that in 1975?
Provide a short and direct response. 1. What is the ratio of the General Parity Index (GPI) of Barbados in 1973 to that in 1975?
Ensure brevity in your answer.  0.98. What is the ratio of the General Parity Index (GPI) in Brunei Darussalam in 1973 to that in 1975?
Your answer should be very brief. 0.97. What is the ratio of the General Parity Index (GPI) of Euro area in 1973 to that in 1976?
Give a very brief answer. 0.98. What is the ratio of the General Parity Index (GPI) in Low income in 1973 to that in 1976?
Keep it short and to the point. 0.98. What is the ratio of the General Parity Index (GPI) of Barbados in 1973 to that in 1976?
Your response must be concise. 0.91. What is the ratio of the General Parity Index (GPI) of Brunei Darussalam in 1973 to that in 1976?
Make the answer very short. 0.93. What is the ratio of the General Parity Index (GPI) of Euro area in 1973 to that in 1977?
Your response must be concise. 0.97. What is the ratio of the General Parity Index (GPI) in Low income in 1973 to that in 1977?
Your answer should be compact. 0.98. What is the ratio of the General Parity Index (GPI) of Barbados in 1973 to that in 1977?
Make the answer very short. 0.9. What is the ratio of the General Parity Index (GPI) in Brunei Darussalam in 1973 to that in 1977?
Your answer should be very brief. 0.9. What is the ratio of the General Parity Index (GPI) in Euro area in 1973 to that in 1978?
Provide a short and direct response. 0.97. What is the ratio of the General Parity Index (GPI) in Low income in 1973 to that in 1978?
Your response must be concise. 0.98. What is the ratio of the General Parity Index (GPI) of Barbados in 1973 to that in 1978?
Offer a very short reply. 0.92. What is the ratio of the General Parity Index (GPI) in Brunei Darussalam in 1973 to that in 1978?
Your answer should be compact. 0.88. What is the ratio of the General Parity Index (GPI) of Low income in 1974 to that in 1975?
Provide a short and direct response. 1.01. What is the ratio of the General Parity Index (GPI) of Barbados in 1974 to that in 1975?
Offer a very short reply. 0.98. What is the ratio of the General Parity Index (GPI) of Brunei Darussalam in 1974 to that in 1975?
Your response must be concise. 0.98. What is the ratio of the General Parity Index (GPI) of Euro area in 1974 to that in 1976?
Give a very brief answer. 0.97. What is the ratio of the General Parity Index (GPI) in Barbados in 1974 to that in 1976?
Offer a very short reply. 0.9. What is the ratio of the General Parity Index (GPI) in Brunei Darussalam in 1974 to that in 1976?
Give a very brief answer. 0.94. What is the ratio of the General Parity Index (GPI) of Euro area in 1974 to that in 1977?
Provide a short and direct response. 0.97. What is the ratio of the General Parity Index (GPI) in Low income in 1974 to that in 1977?
Offer a terse response. 0.99. What is the ratio of the General Parity Index (GPI) in Barbados in 1974 to that in 1977?
Provide a succinct answer. 0.89. What is the ratio of the General Parity Index (GPI) in Brunei Darussalam in 1974 to that in 1977?
Make the answer very short. 0.91. What is the ratio of the General Parity Index (GPI) in Euro area in 1974 to that in 1978?
Offer a terse response. 0.96. What is the ratio of the General Parity Index (GPI) in Barbados in 1974 to that in 1978?
Offer a terse response. 0.91. What is the ratio of the General Parity Index (GPI) of Brunei Darussalam in 1974 to that in 1978?
Offer a terse response. 0.89. What is the ratio of the General Parity Index (GPI) of Euro area in 1975 to that in 1976?
Your response must be concise. 1. What is the ratio of the General Parity Index (GPI) in Low income in 1975 to that in 1976?
Provide a short and direct response. 0.98. What is the ratio of the General Parity Index (GPI) of Barbados in 1975 to that in 1976?
Make the answer very short. 0.92. What is the ratio of the General Parity Index (GPI) of Brunei Darussalam in 1975 to that in 1976?
Provide a succinct answer. 0.95. What is the ratio of the General Parity Index (GPI) of Euro area in 1975 to that in 1977?
Offer a terse response. 0.99. What is the ratio of the General Parity Index (GPI) in Low income in 1975 to that in 1977?
Offer a terse response. 0.98. What is the ratio of the General Parity Index (GPI) of Barbados in 1975 to that in 1977?
Keep it short and to the point. 0.92. What is the ratio of the General Parity Index (GPI) of Brunei Darussalam in 1975 to that in 1977?
Provide a short and direct response. 0.93. What is the ratio of the General Parity Index (GPI) in Euro area in 1975 to that in 1978?
Your answer should be compact. 0.99. What is the ratio of the General Parity Index (GPI) in Low income in 1975 to that in 1978?
Your response must be concise. 0.99. What is the ratio of the General Parity Index (GPI) of Barbados in 1975 to that in 1978?
Provide a short and direct response. 0.93. What is the ratio of the General Parity Index (GPI) in Brunei Darussalam in 1975 to that in 1978?
Keep it short and to the point. 0.91. What is the ratio of the General Parity Index (GPI) of Euro area in 1976 to that in 1977?
Make the answer very short. 1. What is the ratio of the General Parity Index (GPI) in Low income in 1976 to that in 1977?
Your answer should be compact. 1. What is the ratio of the General Parity Index (GPI) of Brunei Darussalam in 1976 to that in 1977?
Make the answer very short. 0.97. What is the ratio of the General Parity Index (GPI) in Euro area in 1976 to that in 1978?
Keep it short and to the point. 0.99. What is the ratio of the General Parity Index (GPI) of Barbados in 1976 to that in 1978?
Your answer should be compact. 1.01. What is the ratio of the General Parity Index (GPI) in Brunei Darussalam in 1976 to that in 1978?
Your answer should be compact. 0.95. What is the ratio of the General Parity Index (GPI) in Euro area in 1977 to that in 1978?
Make the answer very short. 0.99. What is the ratio of the General Parity Index (GPI) of Barbados in 1977 to that in 1978?
Offer a very short reply. 1.02. What is the difference between the highest and the second highest General Parity Index (GPI) of Euro area?
Your answer should be compact. 0.01. What is the difference between the highest and the second highest General Parity Index (GPI) in Low income?
Offer a very short reply. 0. What is the difference between the highest and the second highest General Parity Index (GPI) in Barbados?
Offer a very short reply. 0.01. What is the difference between the highest and the second highest General Parity Index (GPI) in Brunei Darussalam?
Your response must be concise. 0.02. What is the difference between the highest and the lowest General Parity Index (GPI) in Euro area?
Keep it short and to the point. 0.04. What is the difference between the highest and the lowest General Parity Index (GPI) in Low income?
Provide a succinct answer. 0.02. What is the difference between the highest and the lowest General Parity Index (GPI) in Barbados?
Keep it short and to the point. 0.12. What is the difference between the highest and the lowest General Parity Index (GPI) of Brunei Darussalam?
Make the answer very short. 0.15. 